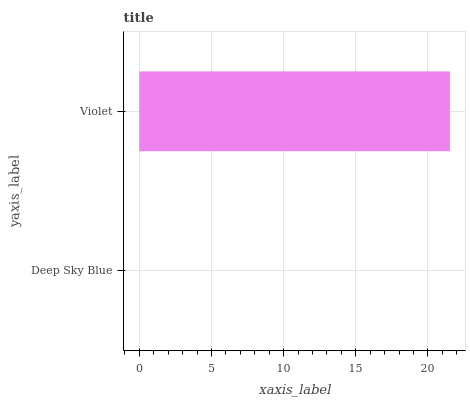Is Deep Sky Blue the minimum?
Answer yes or no. Yes. Is Violet the maximum?
Answer yes or no. Yes. Is Violet the minimum?
Answer yes or no. No. Is Violet greater than Deep Sky Blue?
Answer yes or no. Yes. Is Deep Sky Blue less than Violet?
Answer yes or no. Yes. Is Deep Sky Blue greater than Violet?
Answer yes or no. No. Is Violet less than Deep Sky Blue?
Answer yes or no. No. Is Violet the high median?
Answer yes or no. Yes. Is Deep Sky Blue the low median?
Answer yes or no. Yes. Is Deep Sky Blue the high median?
Answer yes or no. No. Is Violet the low median?
Answer yes or no. No. 